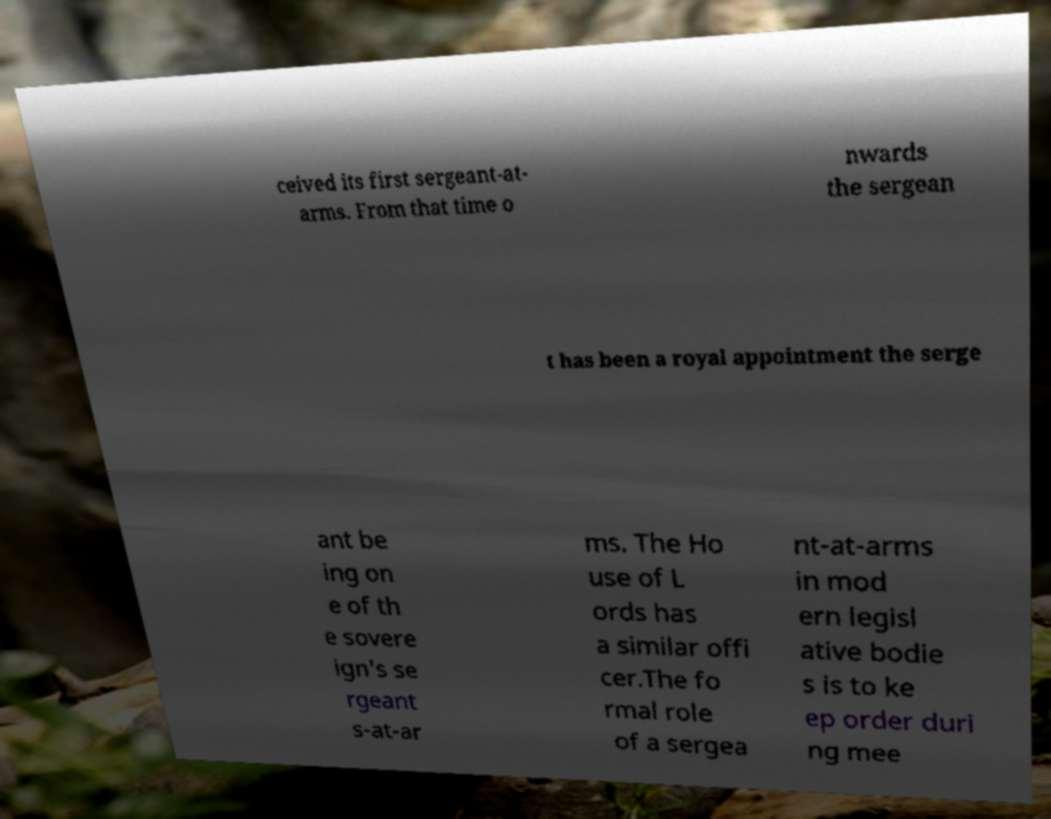For documentation purposes, I need the text within this image transcribed. Could you provide that? ceived its first sergeant-at- arms. From that time o nwards the sergean t has been a royal appointment the serge ant be ing on e of th e sovere ign's se rgeant s-at-ar ms. The Ho use of L ords has a similar offi cer.The fo rmal role of a sergea nt-at-arms in mod ern legisl ative bodie s is to ke ep order duri ng mee 